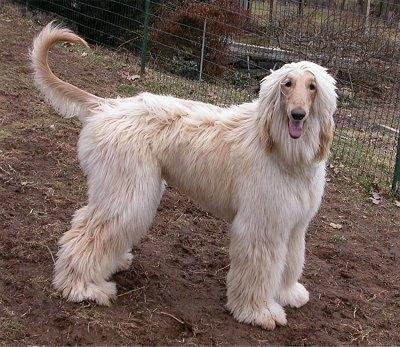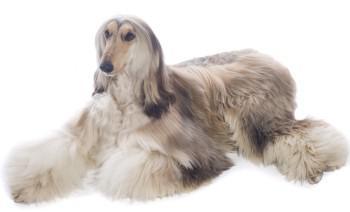The first image is the image on the left, the second image is the image on the right. Evaluate the accuracy of this statement regarding the images: "Four dog feet are visible in the image on the left.". Is it true? Answer yes or no. Yes. 